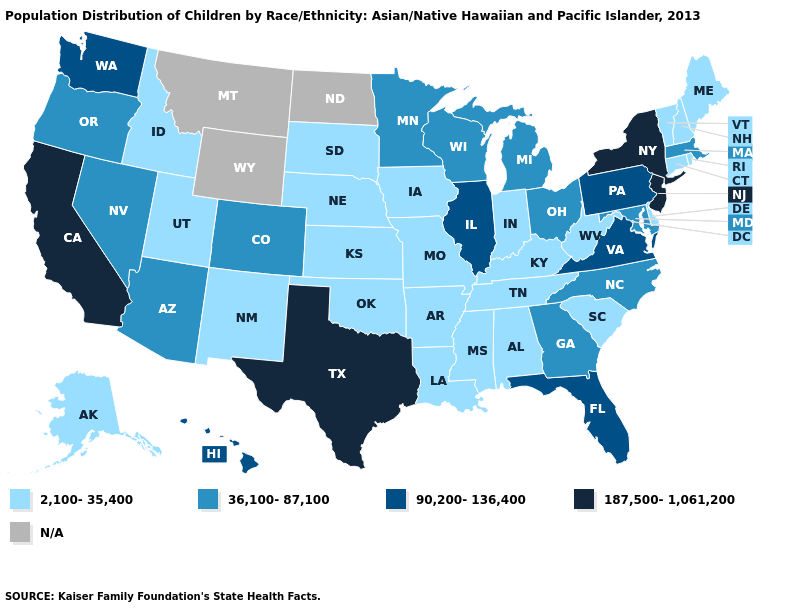What is the lowest value in states that border Utah?
Concise answer only. 2,100-35,400. Name the states that have a value in the range N/A?
Answer briefly. Montana, North Dakota, Wyoming. Name the states that have a value in the range 2,100-35,400?
Answer briefly. Alabama, Alaska, Arkansas, Connecticut, Delaware, Idaho, Indiana, Iowa, Kansas, Kentucky, Louisiana, Maine, Mississippi, Missouri, Nebraska, New Hampshire, New Mexico, Oklahoma, Rhode Island, South Carolina, South Dakota, Tennessee, Utah, Vermont, West Virginia. Name the states that have a value in the range 36,100-87,100?
Write a very short answer. Arizona, Colorado, Georgia, Maryland, Massachusetts, Michigan, Minnesota, Nevada, North Carolina, Ohio, Oregon, Wisconsin. What is the value of Connecticut?
Short answer required. 2,100-35,400. Name the states that have a value in the range N/A?
Keep it brief. Montana, North Dakota, Wyoming. Name the states that have a value in the range 36,100-87,100?
Answer briefly. Arizona, Colorado, Georgia, Maryland, Massachusetts, Michigan, Minnesota, Nevada, North Carolina, Ohio, Oregon, Wisconsin. Name the states that have a value in the range 2,100-35,400?
Write a very short answer. Alabama, Alaska, Arkansas, Connecticut, Delaware, Idaho, Indiana, Iowa, Kansas, Kentucky, Louisiana, Maine, Mississippi, Missouri, Nebraska, New Hampshire, New Mexico, Oklahoma, Rhode Island, South Carolina, South Dakota, Tennessee, Utah, Vermont, West Virginia. What is the value of Wisconsin?
Write a very short answer. 36,100-87,100. Which states have the lowest value in the MidWest?
Write a very short answer. Indiana, Iowa, Kansas, Missouri, Nebraska, South Dakota. Name the states that have a value in the range N/A?
Answer briefly. Montana, North Dakota, Wyoming. What is the value of Missouri?
Write a very short answer. 2,100-35,400. Name the states that have a value in the range 2,100-35,400?
Short answer required. Alabama, Alaska, Arkansas, Connecticut, Delaware, Idaho, Indiana, Iowa, Kansas, Kentucky, Louisiana, Maine, Mississippi, Missouri, Nebraska, New Hampshire, New Mexico, Oklahoma, Rhode Island, South Carolina, South Dakota, Tennessee, Utah, Vermont, West Virginia. Name the states that have a value in the range 90,200-136,400?
Give a very brief answer. Florida, Hawaii, Illinois, Pennsylvania, Virginia, Washington. 